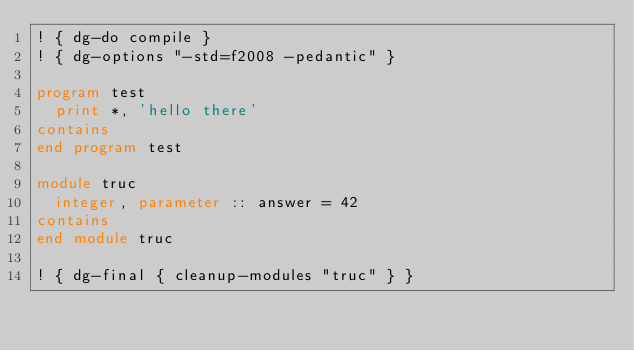<code> <loc_0><loc_0><loc_500><loc_500><_FORTRAN_>! { dg-do compile }
! { dg-options "-std=f2008 -pedantic" }

program test
  print *, 'hello there'
contains
end program test

module truc
  integer, parameter :: answer = 42
contains
end module truc

! { dg-final { cleanup-modules "truc" } }
</code> 